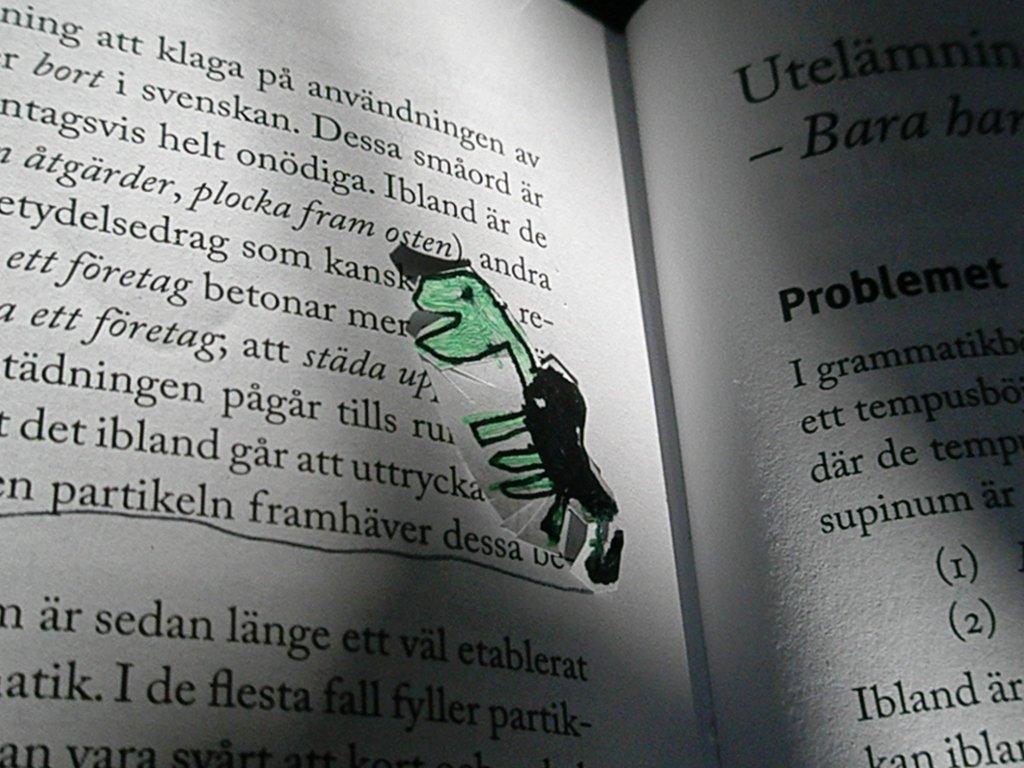What three words are underlined?
Offer a terse response. Partikeln framhaver dessa. 